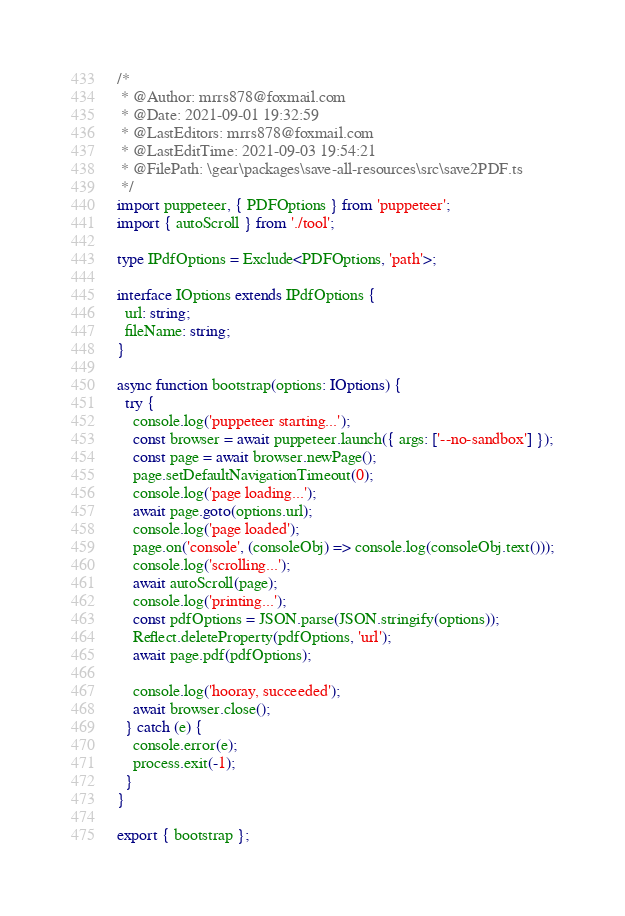<code> <loc_0><loc_0><loc_500><loc_500><_TypeScript_>/*
 * @Author: mrrs878@foxmail.com
 * @Date: 2021-09-01 19:32:59
 * @LastEditors: mrrs878@foxmail.com
 * @LastEditTime: 2021-09-03 19:54:21
 * @FilePath: \gear\packages\save-all-resources\src\save2PDF.ts
 */
import puppeteer, { PDFOptions } from 'puppeteer';
import { autoScroll } from './tool';

type IPdfOptions = Exclude<PDFOptions, 'path'>;

interface IOptions extends IPdfOptions {
  url: string;
  fileName: string;
}

async function bootstrap(options: IOptions) {
  try {
    console.log('puppeteer starting...');
    const browser = await puppeteer.launch({ args: ['--no-sandbox'] });
    const page = await browser.newPage();
    page.setDefaultNavigationTimeout(0);
    console.log('page loading...');
    await page.goto(options.url);
    console.log('page loaded');
    page.on('console', (consoleObj) => console.log(consoleObj.text()));
    console.log('scrolling...');
    await autoScroll(page);
    console.log('printing...');
    const pdfOptions = JSON.parse(JSON.stringify(options));
    Reflect.deleteProperty(pdfOptions, 'url');
    await page.pdf(pdfOptions);

    console.log('hooray, succeeded');
    await browser.close();
  } catch (e) {
    console.error(e);
    process.exit(-1);
  }
}

export { bootstrap };
</code> 